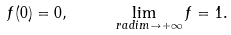Convert formula to latex. <formula><loc_0><loc_0><loc_500><loc_500>f ( 0 ) = 0 , \quad \lim _ { \ r a d i m \to + \infty } f = 1 .</formula> 